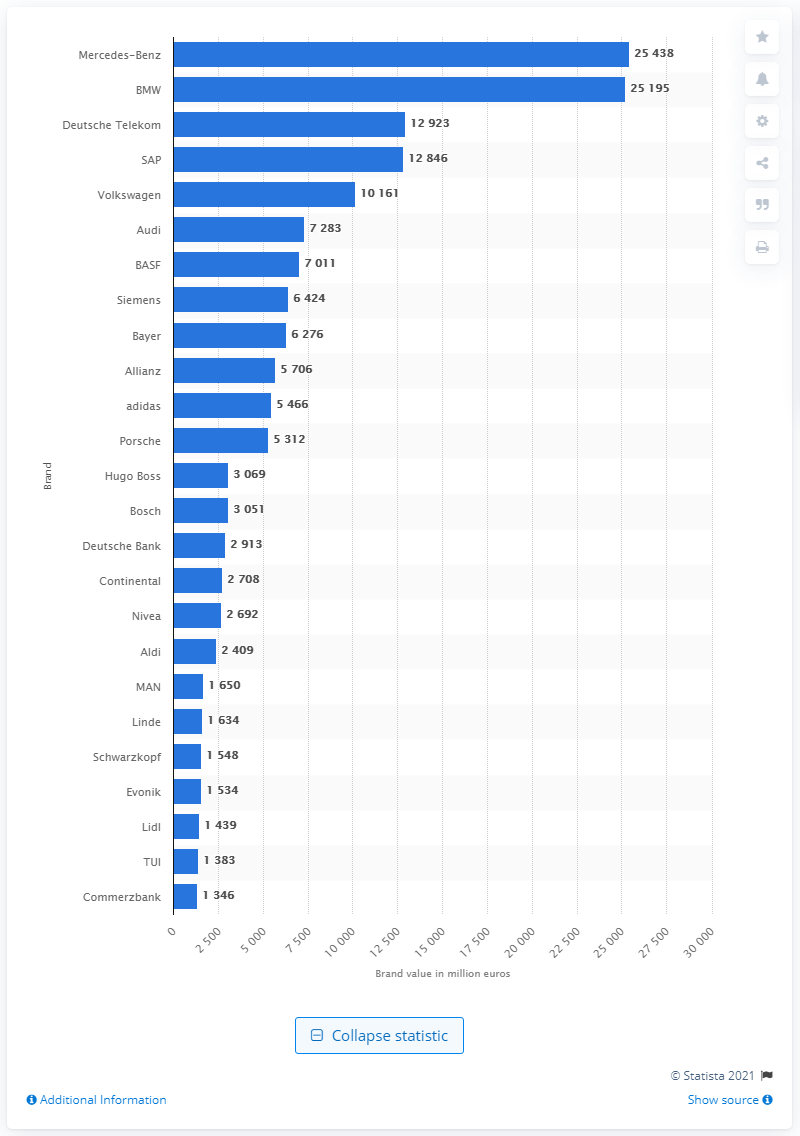Draw attention to some important aspects in this diagram. In 2015, Mercedes-Benz was the most valuable German brand. Deutsche Telekom is the second most valuable German brand. 